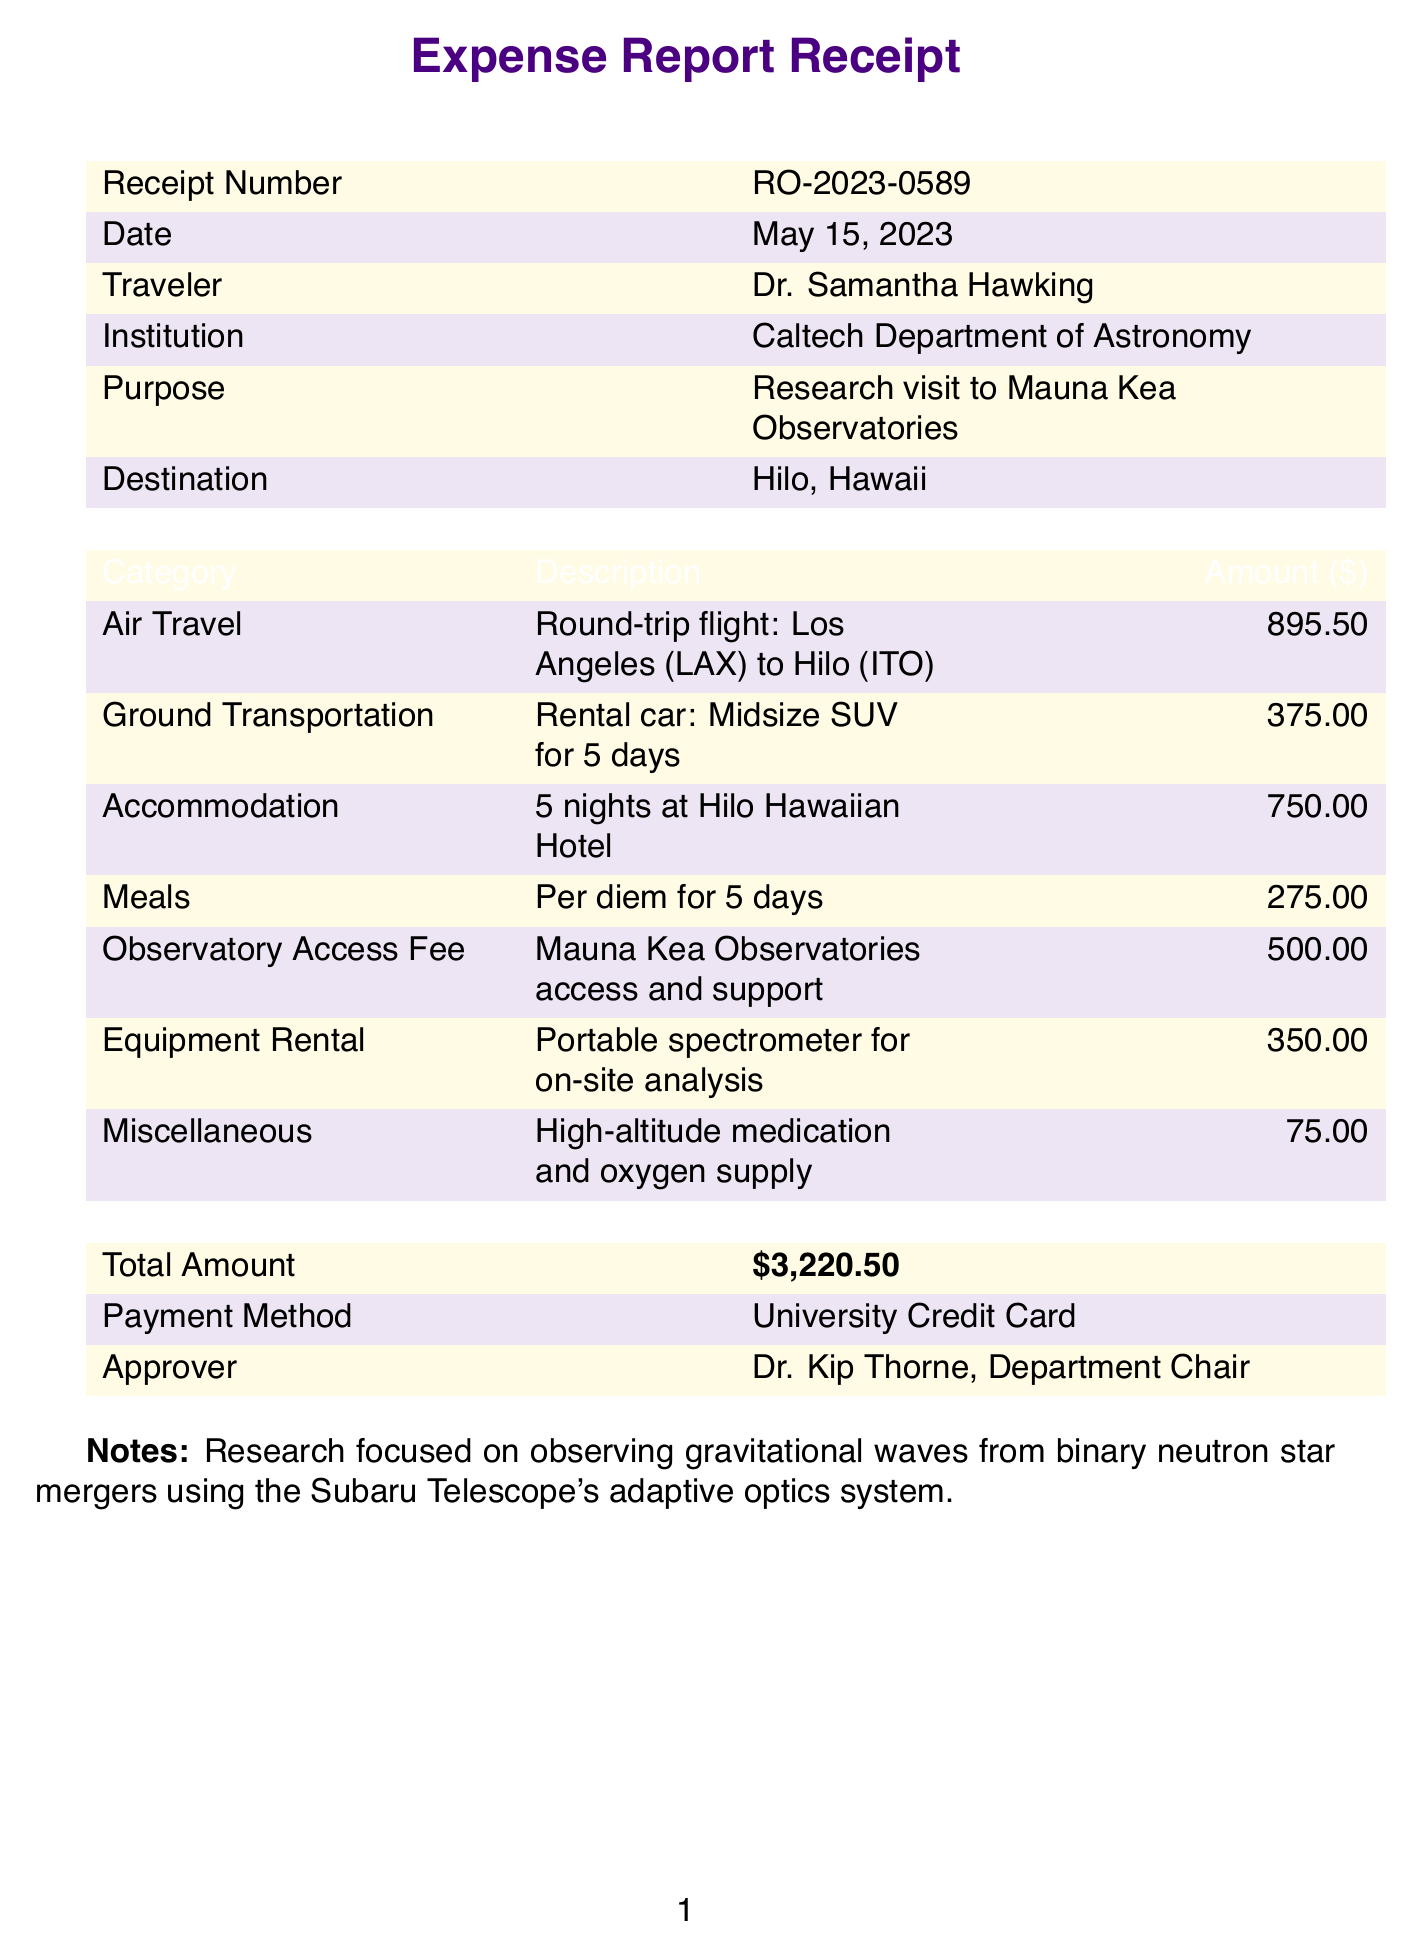What is the receipt number? The receipt number is explicitly stated in the document, which is RO-2023-0589.
Answer: RO-2023-0589 Who is the traveler? The traveler's name is mentioned prominently in the document, which is Dr. Samantha Hawking.
Answer: Dr. Samantha Hawking What was the total amount of the expenses? The total amount can be found in the summary of the document, which shows $3,220.50.
Answer: $3,220.50 What is the purpose of the trip? The purpose is detailed in the document and is related to a research visit to the observatories.
Answer: Research visit to Mauna Kea Observatories Which airline was used for the air travel? The specific airline used for the round-trip flight is mentioned in the document, which is Hawaiian Airlines.
Answer: Hawaiian Airlines What accommodation was booked? The document specifies the accommodation, which is the Hilo Hawaiian Hotel for 5 nights.
Answer: Hilo Hawaiian Hotel How many days was the rental car used? The duration for which the rental car was secured is explicitly stated in the document.
Answer: 5 days Who approved the expense report? The approver's name is listed in the document as Dr. Kip Thorne.
Answer: Dr. Kip Thorne What is included in the miscellaneous expenses? The miscellaneous expenses are detailed in the document, which is high-altitude medication and oxygen supply.
Answer: High-altitude medication and oxygen supply 